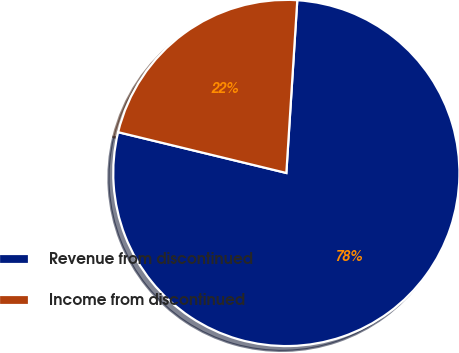<chart> <loc_0><loc_0><loc_500><loc_500><pie_chart><fcel>Revenue from discontinued<fcel>Income from discontinued<nl><fcel>77.78%<fcel>22.22%<nl></chart> 